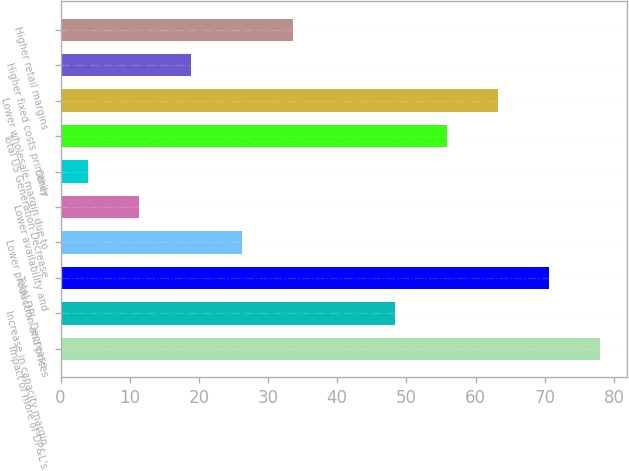Convert chart. <chart><loc_0><loc_0><loc_500><loc_500><bar_chart><fcel>Impact of more of DP&L's<fcel>Increase in capacity margin<fcel>Total DPL Decrease<fcel>Lower production and prices<fcel>Lower availability and<fcel>Other<fcel>Total US Generation Decrease<fcel>Lower wholesale margin due to<fcel>Higher fixed costs primarily<fcel>Higher retail margins<nl><fcel>78<fcel>48.4<fcel>70.6<fcel>26.2<fcel>11.4<fcel>4<fcel>55.8<fcel>63.2<fcel>18.8<fcel>33.6<nl></chart> 